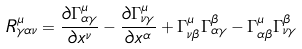<formula> <loc_0><loc_0><loc_500><loc_500>R ^ { \mu } _ { \gamma \alpha \nu } = \frac { \partial \Gamma ^ { \mu } _ { \alpha \gamma } } { \partial x ^ { \nu } } - \frac { \partial \Gamma ^ { \mu } _ { \nu \gamma } } { \partial x ^ { \alpha } } + \Gamma ^ { \mu } _ { \nu \beta } \Gamma ^ { \beta } _ { \alpha \gamma } - \Gamma ^ { \mu } _ { \alpha \beta } \Gamma ^ { \beta } _ { \nu \gamma }</formula> 